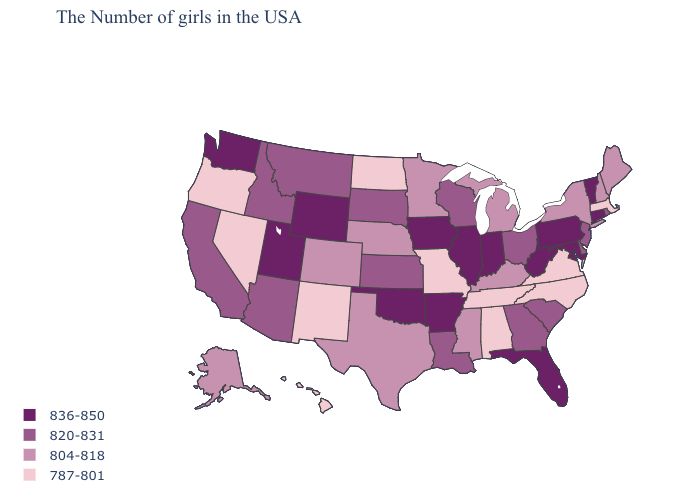Does Arkansas have the lowest value in the USA?
Be succinct. No. Name the states that have a value in the range 787-801?
Keep it brief. Massachusetts, Virginia, North Carolina, Alabama, Tennessee, Missouri, North Dakota, New Mexico, Nevada, Oregon, Hawaii. What is the lowest value in the West?
Short answer required. 787-801. How many symbols are there in the legend?
Be succinct. 4. Name the states that have a value in the range 820-831?
Quick response, please. Rhode Island, New Jersey, Delaware, South Carolina, Ohio, Georgia, Wisconsin, Louisiana, Kansas, South Dakota, Montana, Arizona, Idaho, California. What is the value of Michigan?
Answer briefly. 804-818. What is the highest value in the West ?
Write a very short answer. 836-850. What is the value of Louisiana?
Concise answer only. 820-831. Which states hav the highest value in the West?
Keep it brief. Wyoming, Utah, Washington. What is the lowest value in states that border Nebraska?
Keep it brief. 787-801. What is the value of South Carolina?
Keep it brief. 820-831. Does North Carolina have the lowest value in the South?
Write a very short answer. Yes. Does Wyoming have the highest value in the USA?
Answer briefly. Yes. What is the value of Pennsylvania?
Keep it brief. 836-850. Which states have the lowest value in the West?
Short answer required. New Mexico, Nevada, Oregon, Hawaii. 